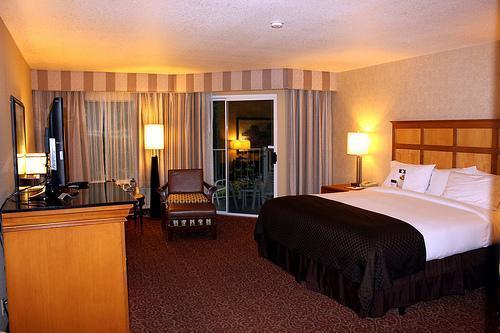How many beds are there?
Give a very brief answer. 1. 